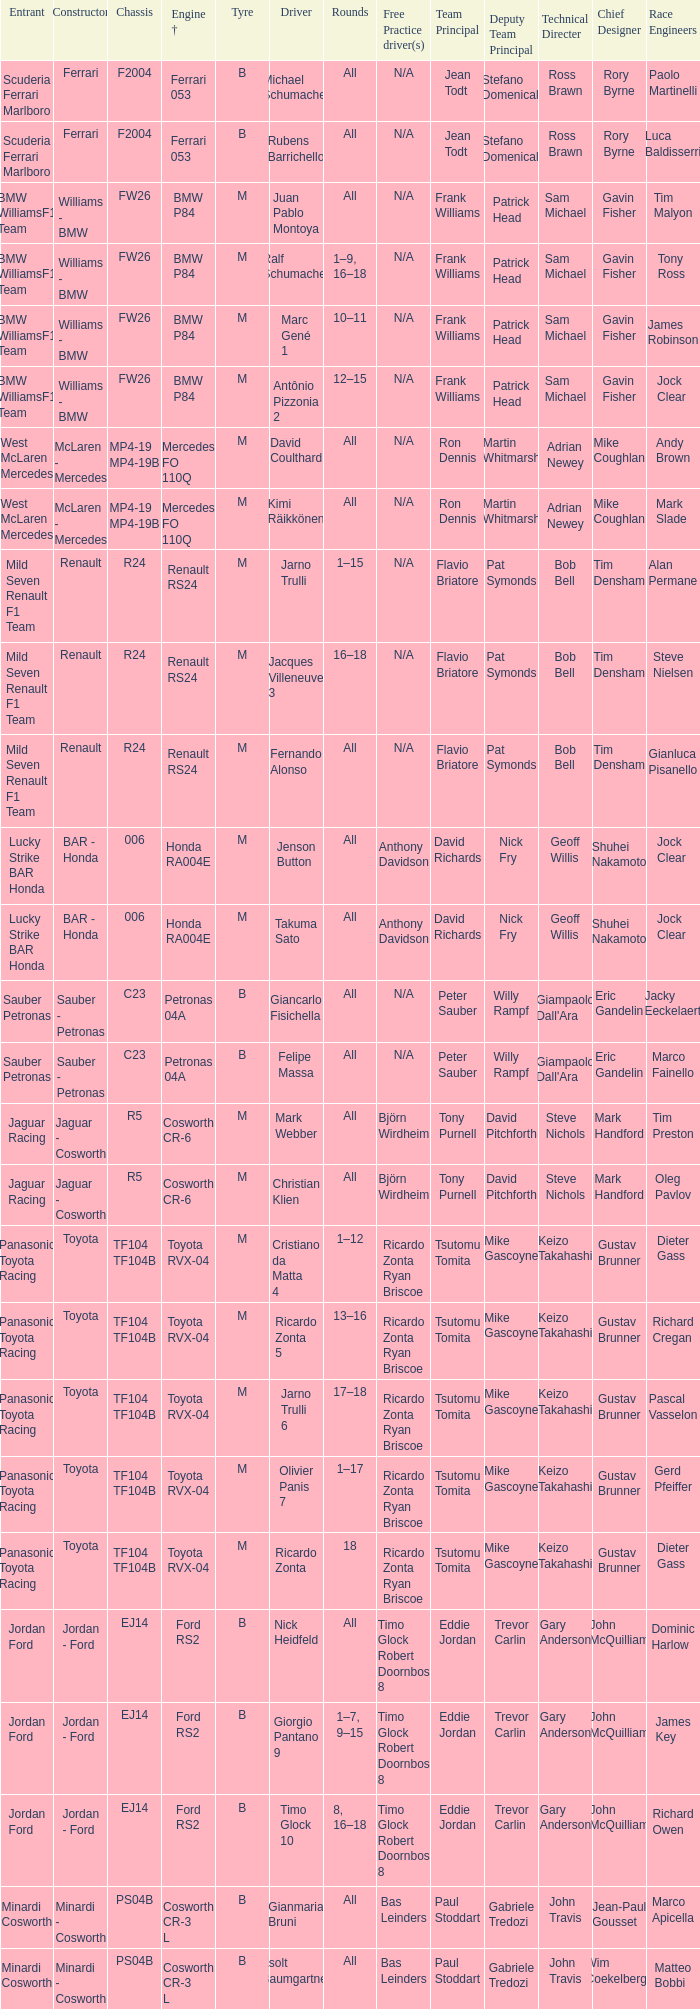What kind of chassis does Ricardo Zonta have? TF104 TF104B. 